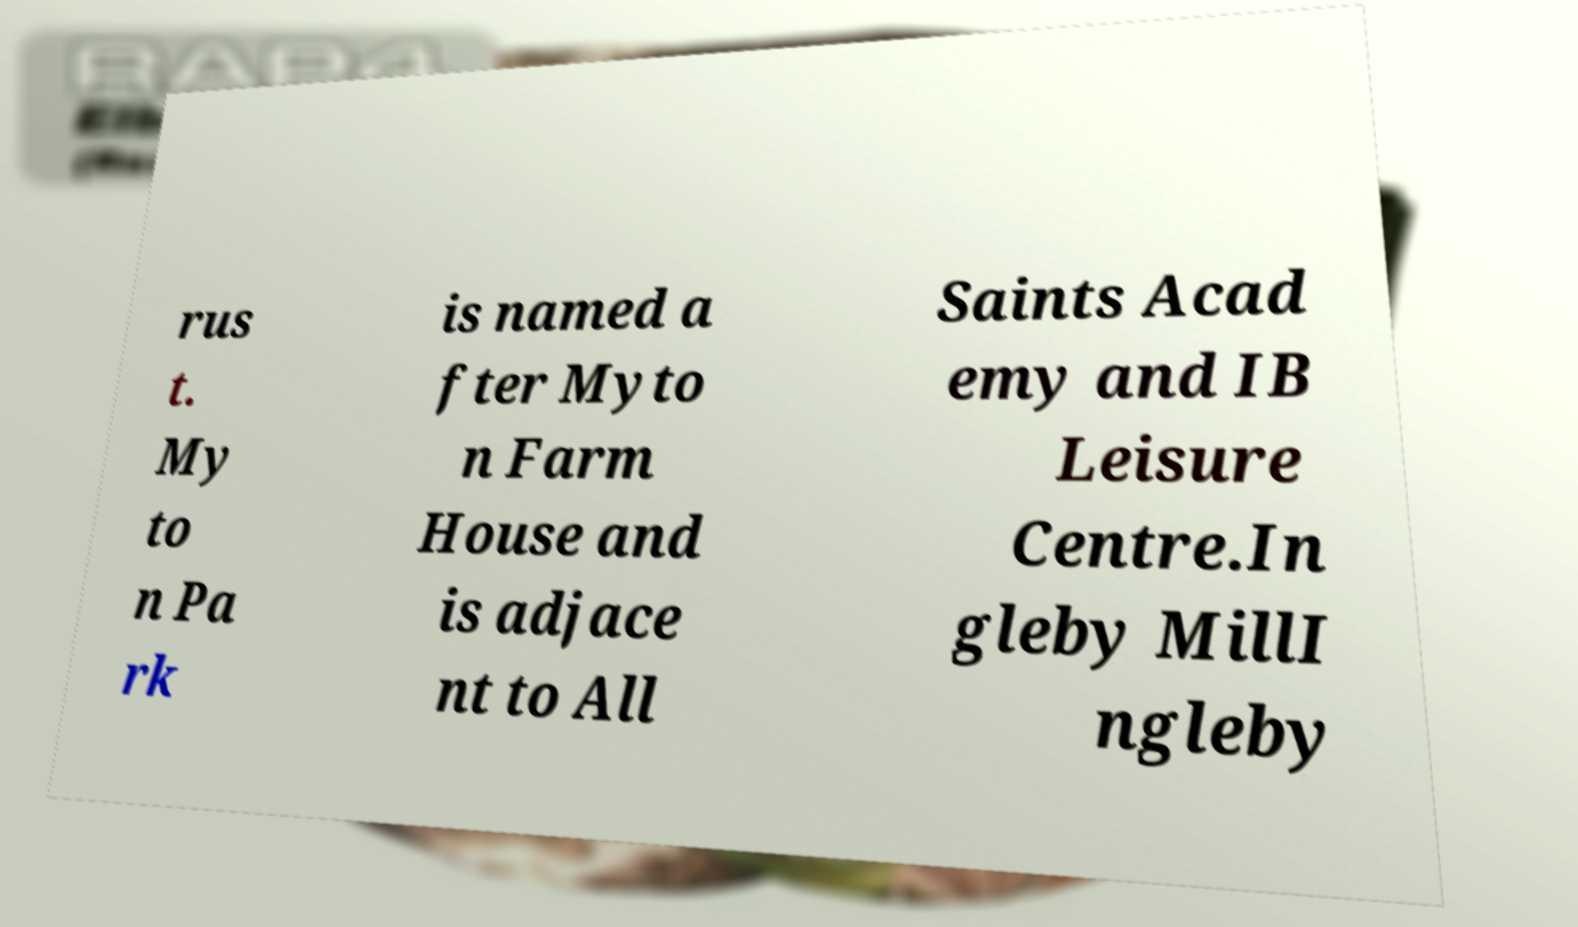Please read and relay the text visible in this image. What does it say? rus t. My to n Pa rk is named a fter Myto n Farm House and is adjace nt to All Saints Acad emy and IB Leisure Centre.In gleby MillI ngleby 